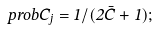<formula> <loc_0><loc_0><loc_500><loc_500>\ p r o b { C _ { j } } = 1 / ( 2 \bar { C } + 1 ) ;</formula> 